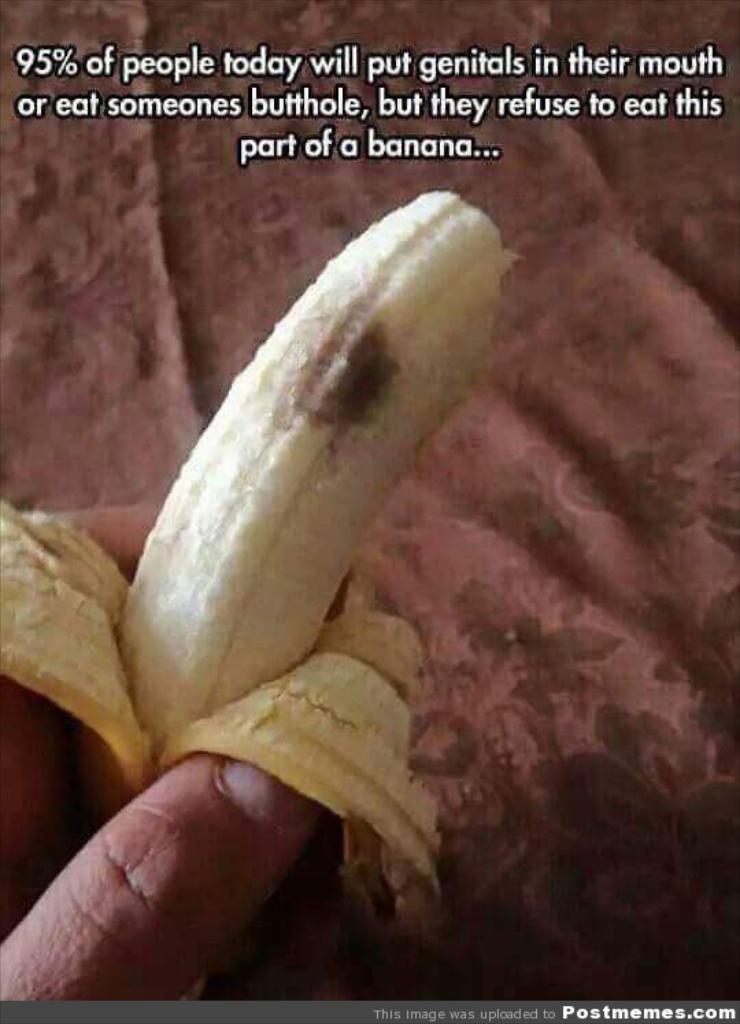Please provide a concise description of this image. This image consists of a person holding banana. In the background, there is bed sheet. At the top, there is a text. 